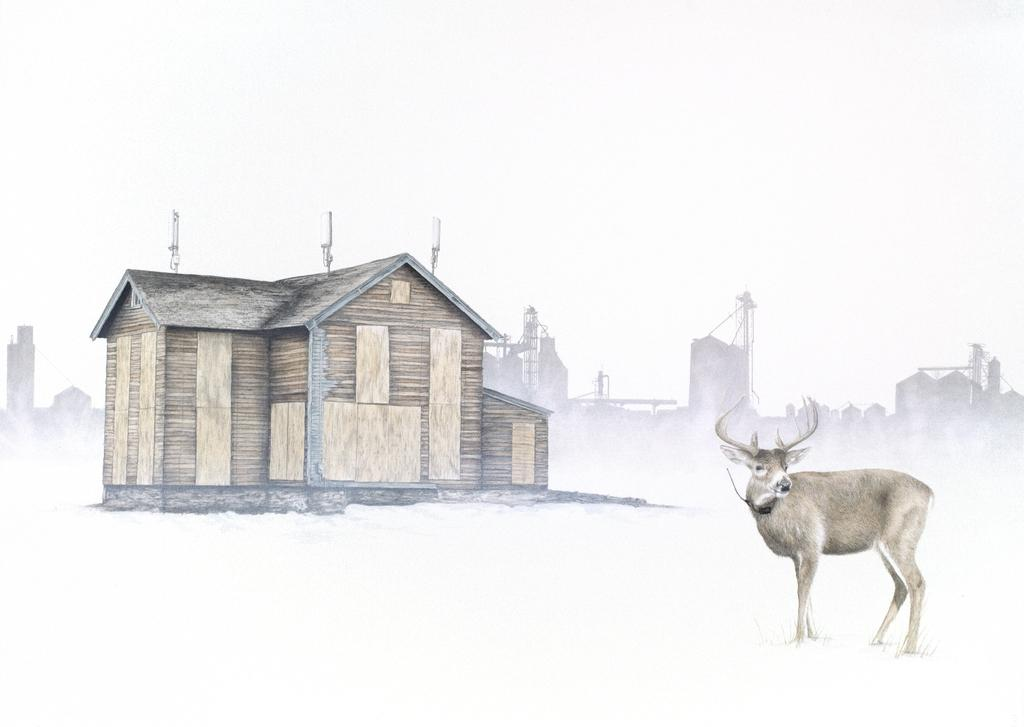What type of structure is visible in the image? There is a house in the image. What other living creature can be seen in the image? There is an animal in the image. What can be seen in the distance behind the house? There are buildings in the background of the image. What is the color of the background in the image? The background of the image is white in color. Can you see a stream of water flowing near the house in the image? There is no stream of water visible in the image. What type of comb is being used by the animal in the image? There is no comb present in the image, and the animal is not using any comb. 